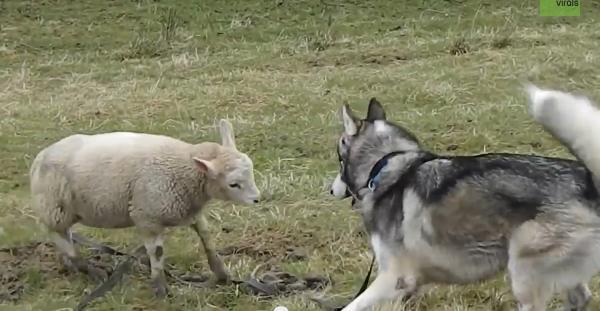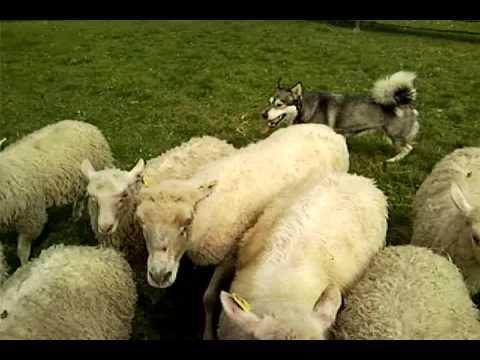The first image is the image on the left, the second image is the image on the right. Evaluate the accuracy of this statement regarding the images: "there are at least 6 husky dogs on a grassy hill". Is it true? Answer yes or no. No. The first image is the image on the left, the second image is the image on the right. Considering the images on both sides, is "There are dogs with sheep in each image" valid? Answer yes or no. Yes. 